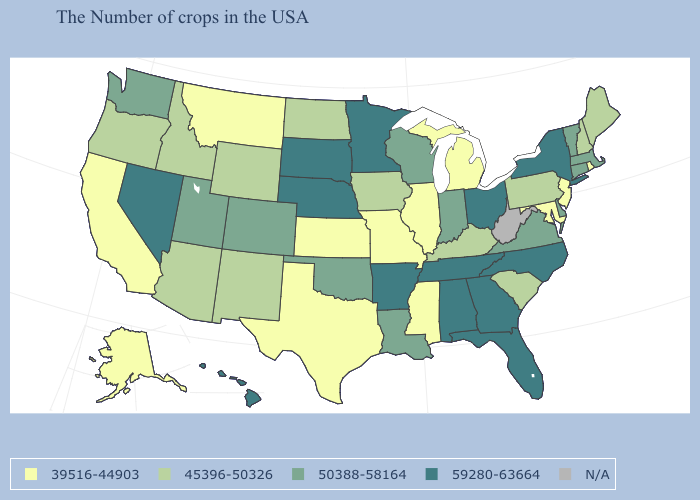What is the lowest value in the USA?
Quick response, please. 39516-44903. What is the value of New Mexico?
Quick response, please. 45396-50326. What is the value of Wisconsin?
Be succinct. 50388-58164. What is the value of Wisconsin?
Be succinct. 50388-58164. How many symbols are there in the legend?
Be succinct. 5. Among the states that border New Mexico , which have the lowest value?
Answer briefly. Texas. Which states hav the highest value in the MidWest?
Be succinct. Ohio, Minnesota, Nebraska, South Dakota. How many symbols are there in the legend?
Short answer required. 5. Name the states that have a value in the range N/A?
Quick response, please. West Virginia. What is the lowest value in the Northeast?
Answer briefly. 39516-44903. What is the value of Minnesota?
Write a very short answer. 59280-63664. What is the value of Delaware?
Keep it brief. 50388-58164. What is the value of South Dakota?
Quick response, please. 59280-63664. 